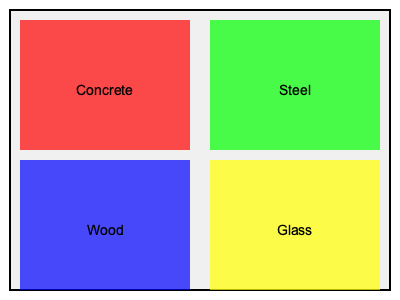Based on the thermal imaging graphic showing heat distribution patterns in various building materials, which material exhibits the highest thermal conductivity? To determine which material has the highest thermal conductivity, we need to analyze the color patterns in the thermal image:

1. Understand the color scale: In thermal imaging, typically warmer colors (red, orange, yellow) indicate higher temperatures, while cooler colors (green, blue) indicate lower temperatures.

2. Analyze each material:
   a) Concrete (top-left): Appears red, indicating high heat retention.
   b) Steel (top-right): Appears green, suggesting moderate heat conduction.
   c) Wood (bottom-left): Appears blue, indicating low heat conduction.
   d) Glass (bottom-right): Appears yellow, suggesting high heat conduction.

3. Consider thermal conductivity properties:
   - Materials with high thermal conductivity will show a more uniform temperature distribution and appear cooler in the image, as they quickly dissipate heat.
   - Materials with low thermal conductivity will retain heat and appear warmer.

4. Compare the materials:
   - Steel has the most uniform and coolest appearance (green), indicating it conducts and dissipates heat most effectively.
   - Glass shows high heat conduction but not as uniform as steel.
   - Concrete and wood retain heat, indicating lower thermal conductivity.

5. Conclusion: Based on the thermal imaging pattern, steel exhibits the characteristics of the highest thermal conductivity among the four materials shown.
Answer: Steel 